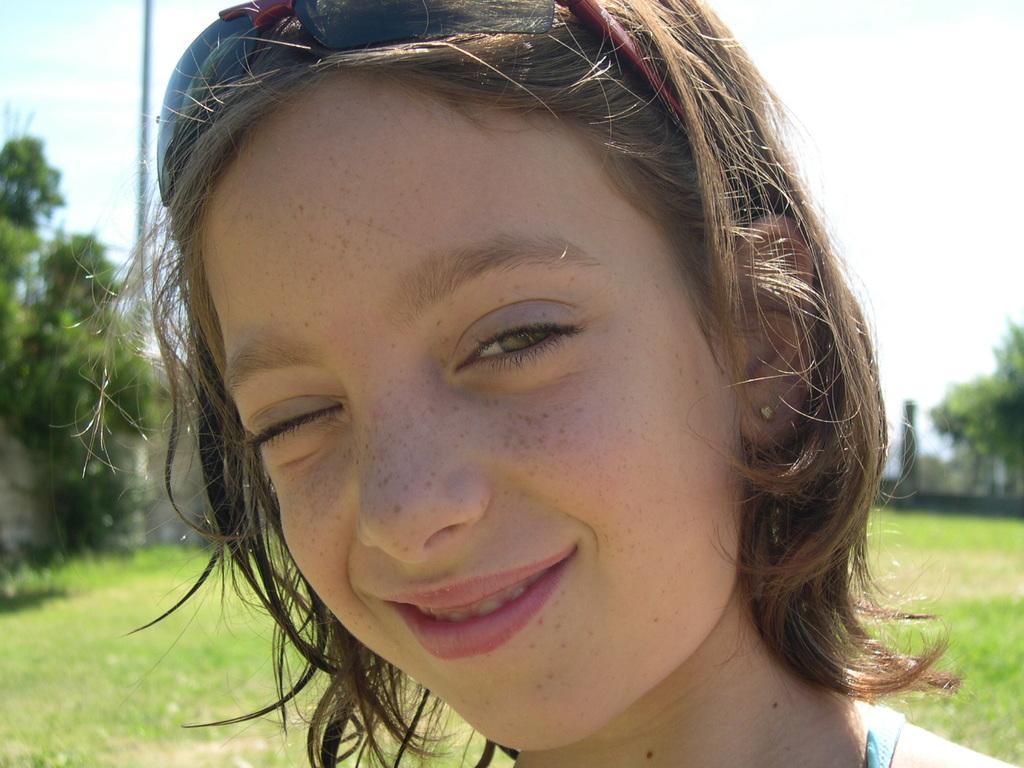Can you describe this image briefly? In this image in the foreground there is one woman, and in the background there are some trees, wall and at the bottom there is grass. 